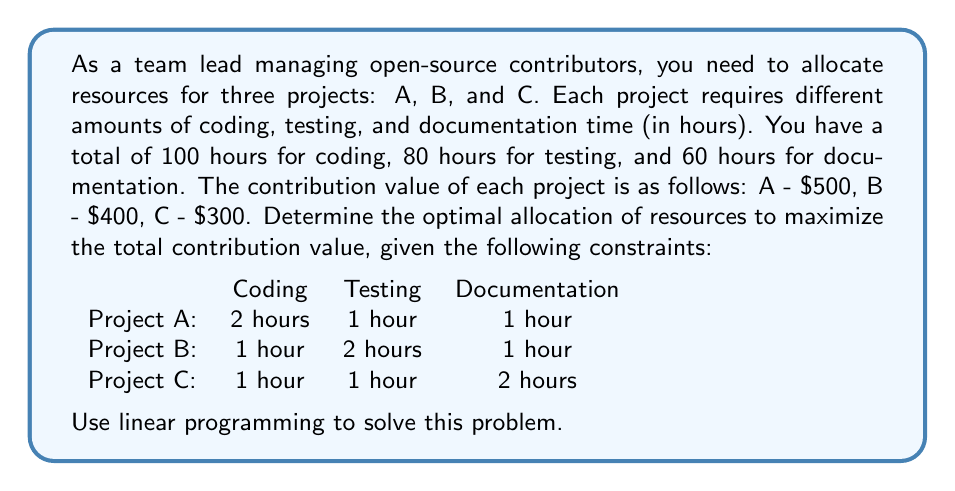Could you help me with this problem? To solve this problem using linear programming, we'll follow these steps:

1. Define variables:
Let $x$, $y$, and $z$ be the number of times projects A, B, and C are completed, respectively.

2. Set up the objective function:
Maximize $Z = 500x + 400y + 300z$

3. Define constraints:
Coding: $2x + y + z \leq 100$
Testing: $x + 2y + z \leq 80$
Documentation: $x + y + 2z \leq 60$
Non-negativity: $x, y, z \geq 0$

4. Solve using the simplex method or graphical method. For this problem, we'll use the graphical method as we have only three variables.

5. First, we'll consider the $x$-$y$ plane by setting $z = 0$:

   Coding: $2x + y \leq 100$
   Testing: $x + 2y \leq 80$
   Documentation: $x + y \leq 60$

6. Plot these constraints:

[asy]
import geometry;

size(200);
defaultpen(fontsize(10pt));

real xmax = 100;
real ymax = 100;

draw((0,0)--(xmax,0), arrow=Arrow(TeXHead));
draw((0,0)--(0,ymax), arrow=Arrow(TeXHead));

label("$x$", (xmax,0), SE);
label("$y$", (0,ymax), NW);

draw((0,100)--(50,0), red);
draw((0,40)--(80,0), blue);
draw((0,60)--(60,0), green);

label("$2x + y = 100$", (25,50), N, red);
label("$x + 2y = 80$", (40,20), S, blue);
label("$x + y = 60$", (30,30), NW, green);

dot((40,20));
dot((20,40));
dot((30,30));

label("(40,20)", (40,20), SE);
label("(20,40)", (20,40), NW);
label("(30,30)", (30,30), SE);
[/asy]

7. The feasible region is the area bounded by these constraints. The optimal solution will be at one of the corner points: (30,30), (40,20), or (20,40).

8. Evaluate the objective function at each point:
   At (30,30,0): $Z = 500(30) + 400(30) + 300(0) = 27,000$
   At (40,20,0): $Z = 500(40) + 400(20) + 300(0) = 28,000$
   At (20,40,0): $Z = 500(20) + 400(40) + 300(0) = 26,000$

9. The maximum value occurs at (40,20,0), but we need to check if including project C can improve the solution.

10. With the remaining resources after allocating to (40,20,0):
    Coding: $100 - (2(40) + 20) = 0$ hours left
    Testing: $80 - (40 + 2(20)) = 0$ hours left
    Documentation: $60 - (40 + 20) = 0$ hours left

11. Since there are no remaining resources, we cannot include project C.

Therefore, the optimal allocation is to complete project A 40 times and project B 20 times, with no resources allocated to project C.
Answer: $x = 40$, $y = 20$, $z = 0$; Total value: $\$28,000$ 